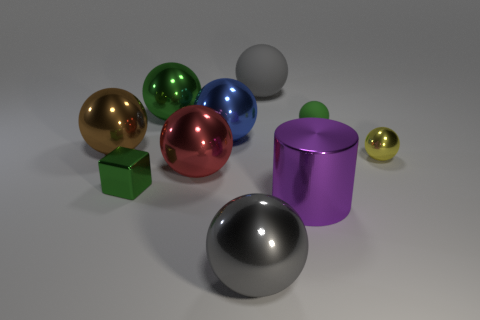Subtract all gray balls. How many balls are left? 6 Subtract all small green balls. How many balls are left? 7 Subtract 3 spheres. How many spheres are left? 5 Subtract all purple balls. Subtract all brown cubes. How many balls are left? 8 Subtract all blocks. How many objects are left? 9 Subtract all purple metallic things. Subtract all large brown balls. How many objects are left? 8 Add 7 small yellow spheres. How many small yellow spheres are left? 8 Add 8 big green cubes. How many big green cubes exist? 8 Subtract 0 cyan spheres. How many objects are left? 10 